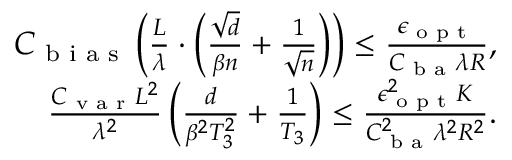Convert formula to latex. <formula><loc_0><loc_0><loc_500><loc_500>\begin{array} { r } { C _ { b i a s } \left ( \frac { L } { \lambda } \cdot \left ( \frac { \sqrt { d } } { \beta n } + \frac { 1 } \sqrt { n } } \right ) \right ) \leq \frac { \epsilon _ { o p t } } { C _ { b a } \lambda R } , } \\ { \frac { C _ { v a r } L ^ { 2 } } { \lambda ^ { 2 } } \left ( \frac { d } { \beta ^ { 2 } T _ { 3 } ^ { 2 } } + \frac { 1 } T _ { 3 } } \right ) \leq \frac { \epsilon _ { o p t } ^ { 2 } K } { C _ { b a } ^ { 2 } \lambda ^ { 2 } R ^ { 2 } } . } \end{array}</formula> 